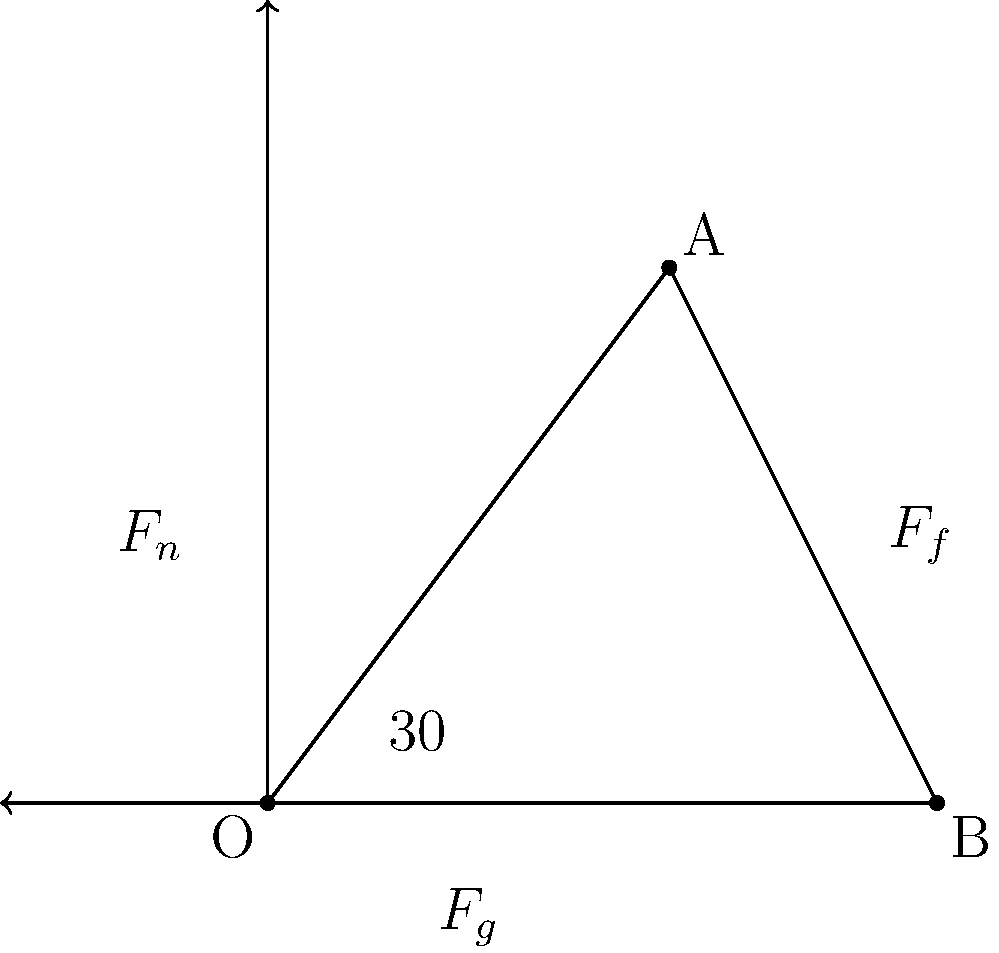During a squash lunge, a player experiences three main forces: gravity ($F_g$), normal force ($F_n$), and friction ($F_f$). If the player's mass is 70 kg and the coefficient of friction between the shoe and the court is 0.6, calculate the magnitude of the friction force when the player's lunge forms a 30° angle with the horizontal. Assume $g = 9.8 \text{ m/s}^2$. To solve this problem, we'll follow these steps:

1) First, we need to calculate the normal force ($F_n$). In this case, it's equal to the component of the weight perpendicular to the surface:

   $F_n = mg \cos(30°)$

2) Calculate the weight of the player:
   $F_g = mg = 70 \text{ kg} \times 9.8 \text{ m/s}^2 = 686 \text{ N}$

3) Now calculate the normal force:
   $F_n = 686 \text{ N} \times \cos(30°) = 686 \text{ N} \times 0.866 = 594.1 \text{ N}$

4) The friction force is given by:
   $F_f = \mu F_n$
   where $\mu$ is the coefficient of friction

5) Substitute the values:
   $F_f = 0.6 \times 594.1 \text{ N} = 356.46 \text{ N}$

Therefore, the magnitude of the friction force is approximately 356.5 N.
Answer: 356.5 N 